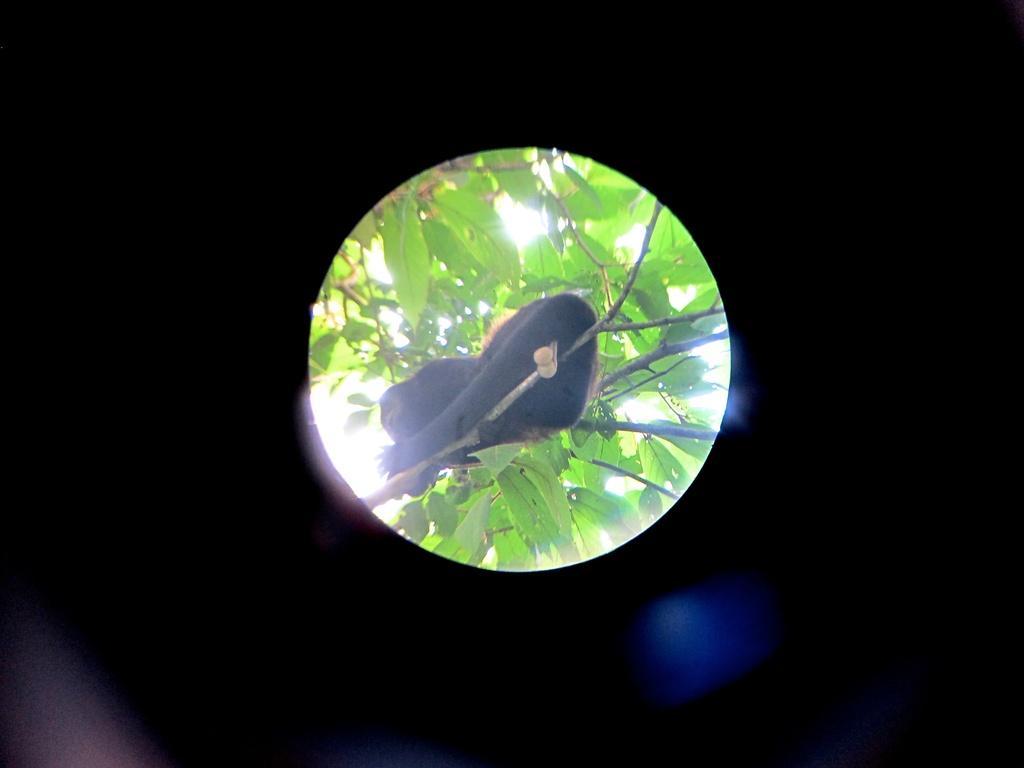How would you summarize this image in a sentence or two? In this image we can see a monkey sitting on the branch of a tree and sky in the background. 